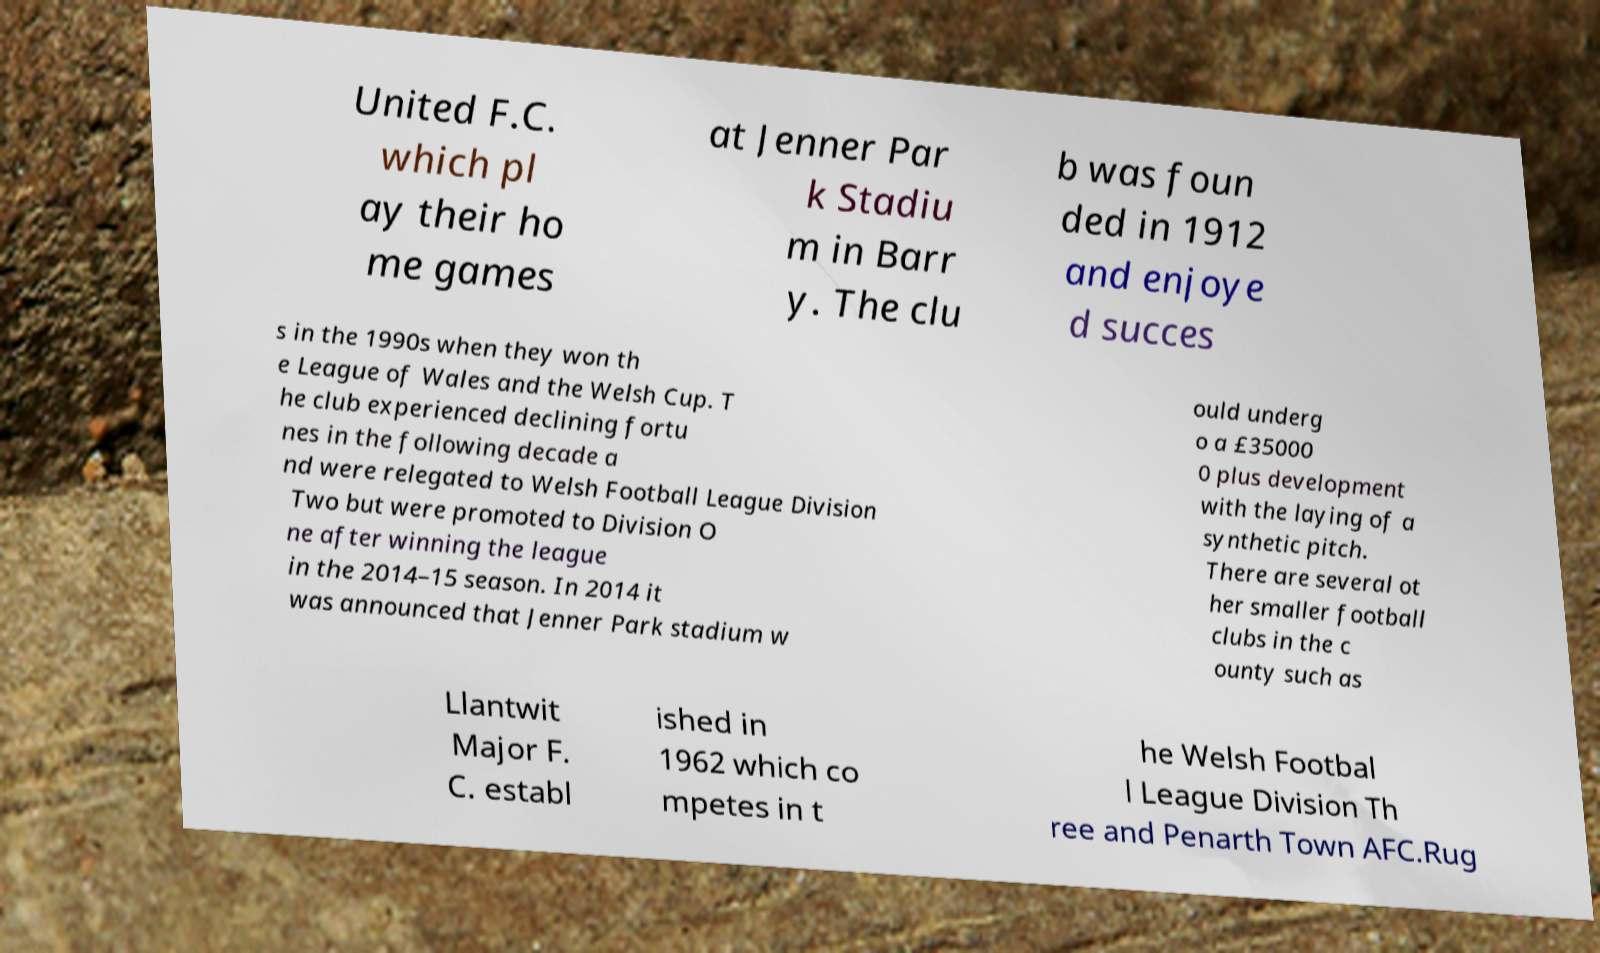I need the written content from this picture converted into text. Can you do that? United F.C. which pl ay their ho me games at Jenner Par k Stadiu m in Barr y. The clu b was foun ded in 1912 and enjoye d succes s in the 1990s when they won th e League of Wales and the Welsh Cup. T he club experienced declining fortu nes in the following decade a nd were relegated to Welsh Football League Division Two but were promoted to Division O ne after winning the league in the 2014–15 season. In 2014 it was announced that Jenner Park stadium w ould underg o a £35000 0 plus development with the laying of a synthetic pitch. There are several ot her smaller football clubs in the c ounty such as Llantwit Major F. C. establ ished in 1962 which co mpetes in t he Welsh Footbal l League Division Th ree and Penarth Town AFC.Rug 